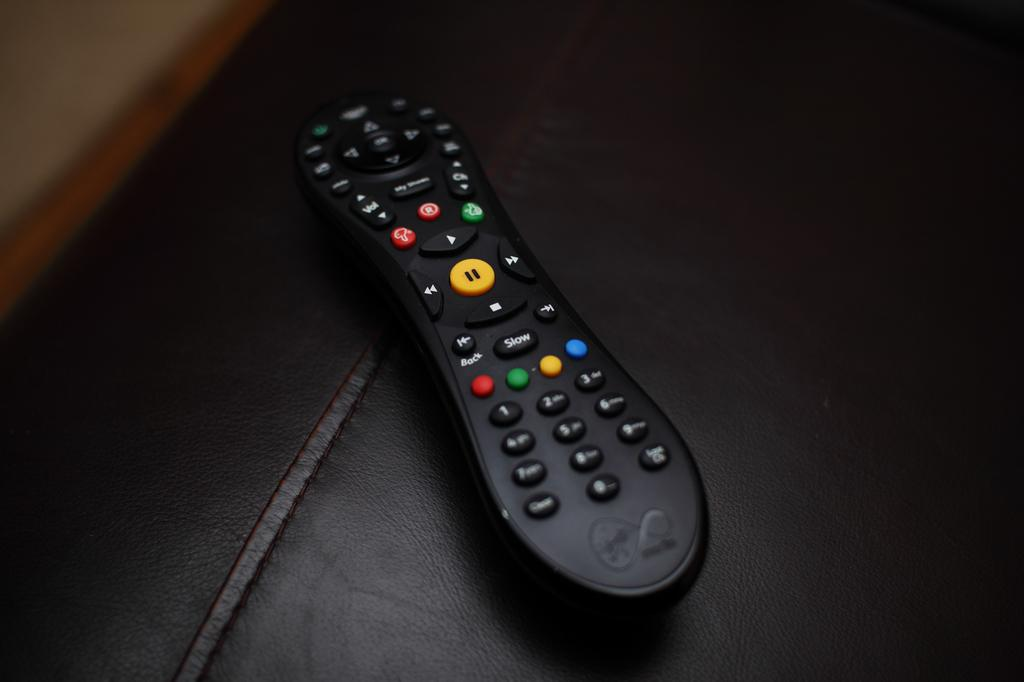<image>
Relay a brief, clear account of the picture shown. A black television multi function control has a button for Slow. 